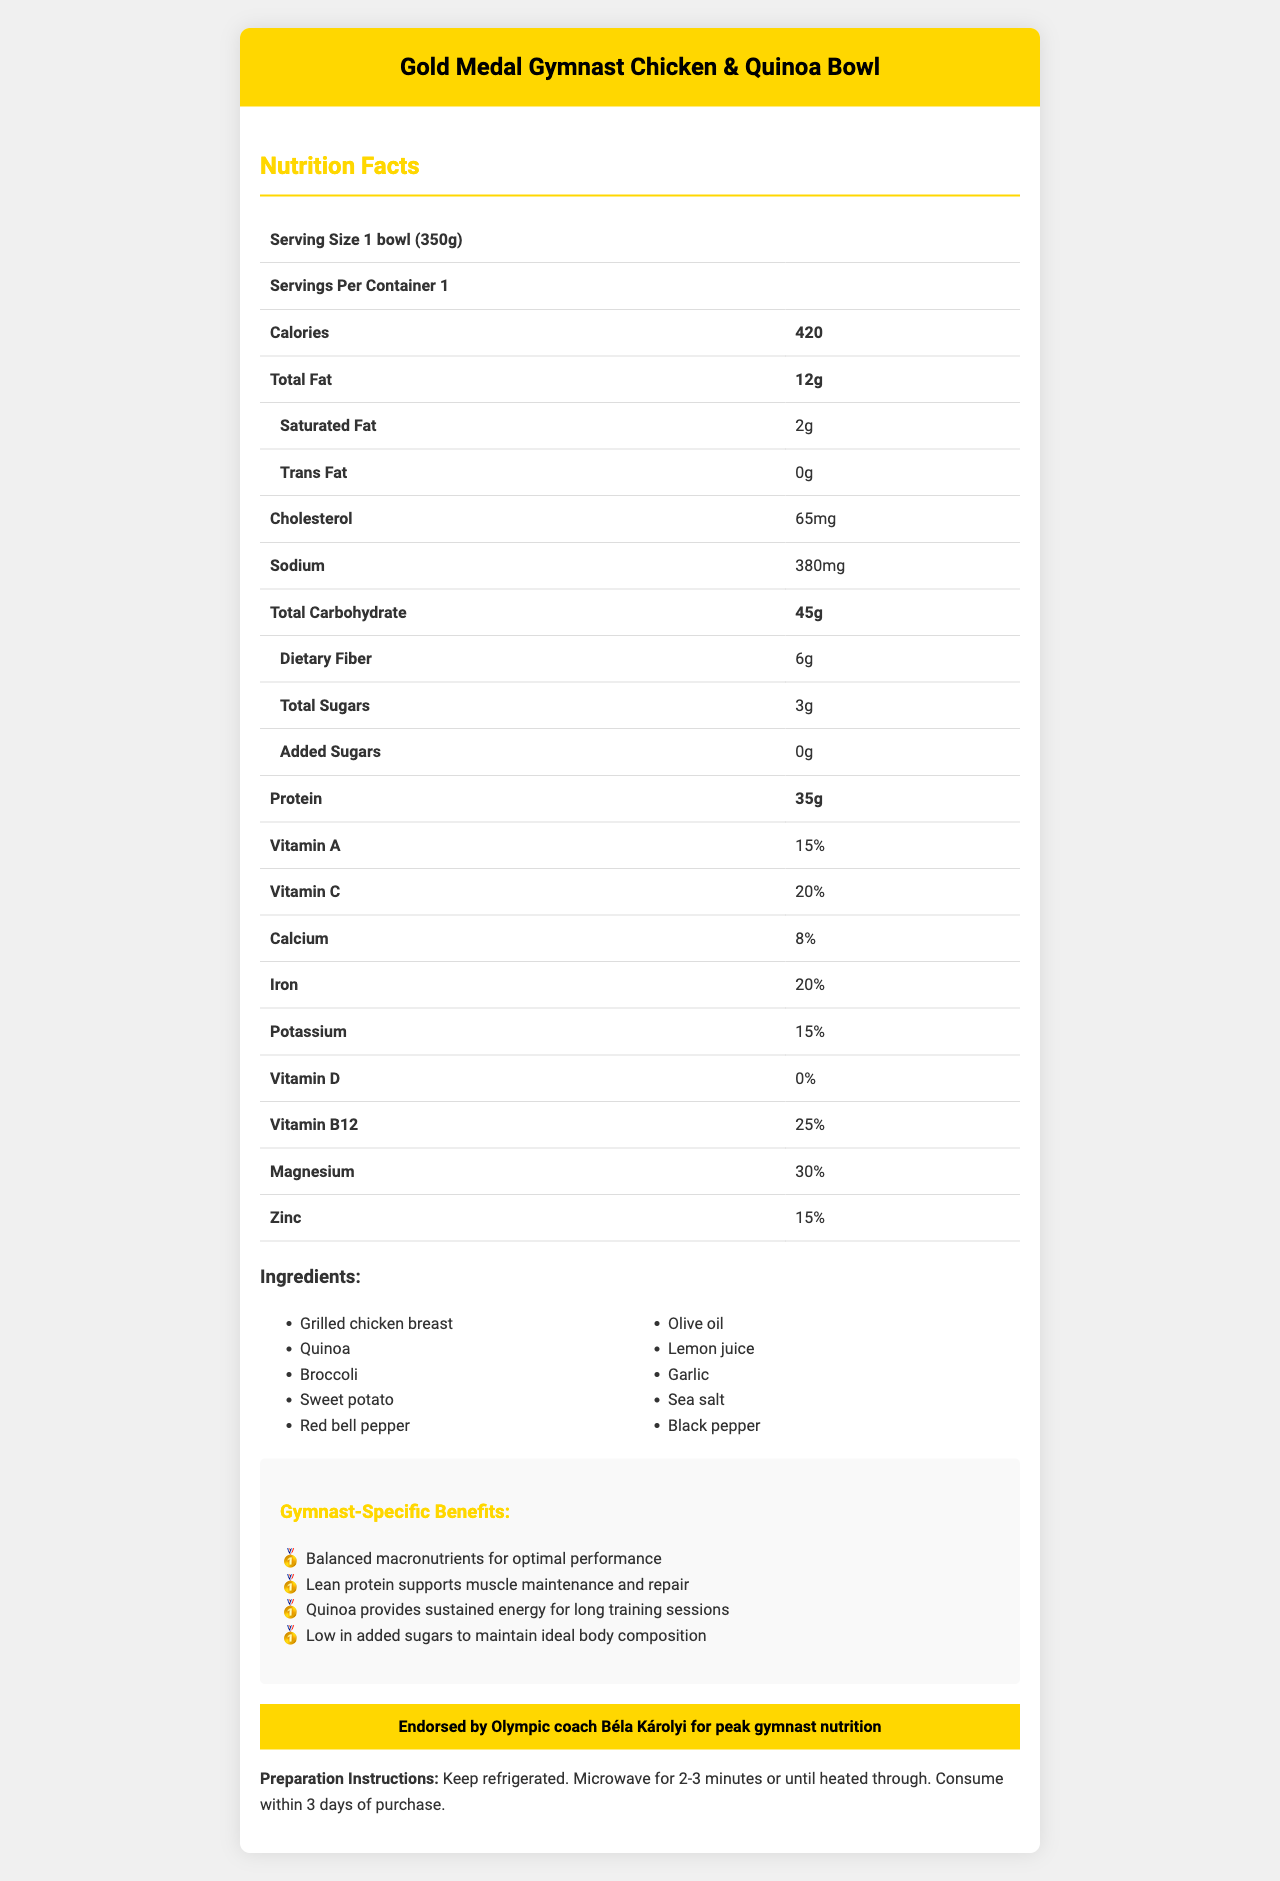Who endorses the Gold Medal Gymnast Chicken & Quinoa Bowl for gymnast nutrition? The document states, "Endorsed by Olympic coach Béla Károlyi for peak gymnast nutrition."
Answer: Olympic coach Béla Károlyi How much protein is in one serving of the meal prep bowl? The nutritional facts table indicates that the protein content is 35g per serving.
Answer: 35g How many calories are there in one bowl? The nutrition facts show that there are 420 calories in one bowl.
Answer: 420 What is the sodium content in one serving? According to the sodium row in the nutrition facts, one serving contains 380mg of sodium.
Answer: 380mg Are there any allergens listed for this meal? The allergens section explicitly states "None."
Answer: No What percentage of your daily iron intake does one serving provide? The iron row in the nutrition facts indicates that one serving provides 20% of the daily iron requirement.
Answer: 20% Which of the following ingredients is NOT part of this meal? A. Grilled chicken breast B. Kale C. Broccoli D. Quinoa The list of ingredients provided does not include kale but includes the other options.
Answer: B. Kale How many grams of total fat are in the meal? A. 10 B. 12 C. 15 D. 18 The nutrition facts state that the meal contains 12g of total fat.
Answer: B. 12 Does this meal contain any trans fat? The nutrition facts show that the trans fat content is 0g, indicating there are no trans fats in this meal.
Answer: No Describe the primary nutritional benefits of this meal for gymnasts. The nutrition facts and sections about gymnast-specific benefits highlight these key nutritional advantages.
Answer: The meal is high in protein for muscle recovery, rich in complex carbohydrates for sustained energy, a good source of fiber for digestive health, and contains essential vitamins and minerals for overall well-being. What is the preparation method for this meal? The preparation instructions clearly outline these steps.
Answer: Keep refrigerated. Microwave for 2-3 minutes or until heated through. Consume within 3 days of purchase. Is this meal high in added sugars? The nutrition facts show that the added sugar content is 0g, indicating the meal is low in added sugars.
Answer: No Can you determine the manufacturing date of the meal? The document does not provide any details about the manufacturing date of the meal.
Answer: Not enough information How much magnesium does one serving of the meal provide? The nutrition facts indicate one serving offers 30% of the daily value of magnesium.
Answer: 30% List all the ingredients used in this meal. The ingredients section lists all the items used in the meal.
Answer: Grilled chicken breast, Quinoa, Broccoli, Sweet potato, Red bell pepper, Olive oil, Lemon juice, Garlic, Sea salt, Black pepper What vitamin is this meal lacking, according to the nutritional information? The row for Vitamin D in the nutrition facts indicates 0%, meaning there is no Vitamin D.
Answer: Vitamin D How many grams of dietary fiber are present per serving? The nutrition facts display that the dietary fiber content is 6g per serving.
Answer: 6g 